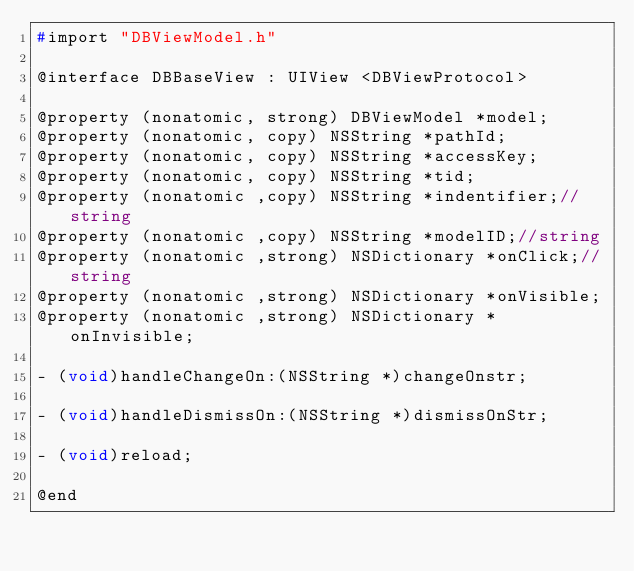<code> <loc_0><loc_0><loc_500><loc_500><_C_>#import "DBViewModel.h"

@interface DBBaseView : UIView <DBViewProtocol>

@property (nonatomic, strong) DBViewModel *model;
@property (nonatomic, copy) NSString *pathId;
@property (nonatomic, copy) NSString *accessKey;
@property (nonatomic, copy) NSString *tid;
@property (nonatomic ,copy) NSString *indentifier;//string
@property (nonatomic ,copy) NSString *modelID;//string
@property (nonatomic ,strong) NSDictionary *onClick;//string
@property (nonatomic ,strong) NSDictionary *onVisible;
@property (nonatomic ,strong) NSDictionary *onInvisible;

- (void)handleChangeOn:(NSString *)changeOnstr;

- (void)handleDismissOn:(NSString *)dismissOnStr;

- (void)reload;

@end

</code> 